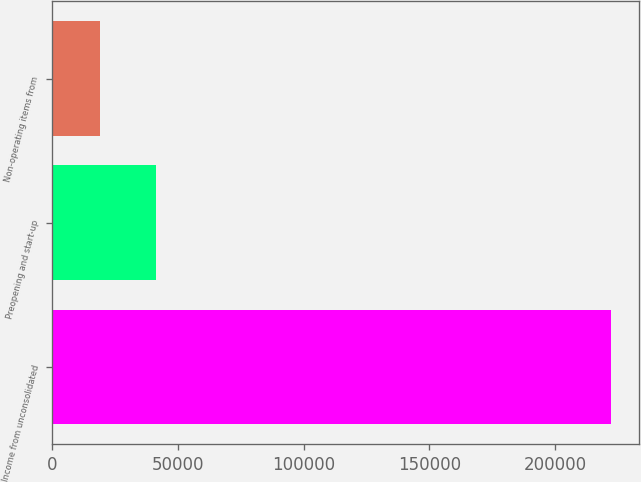Convert chart. <chart><loc_0><loc_0><loc_500><loc_500><bar_chart><fcel>Income from unconsolidated<fcel>Preopening and start-up<fcel>Non-operating items from<nl><fcel>222162<fcel>41140<fcel>18805<nl></chart> 